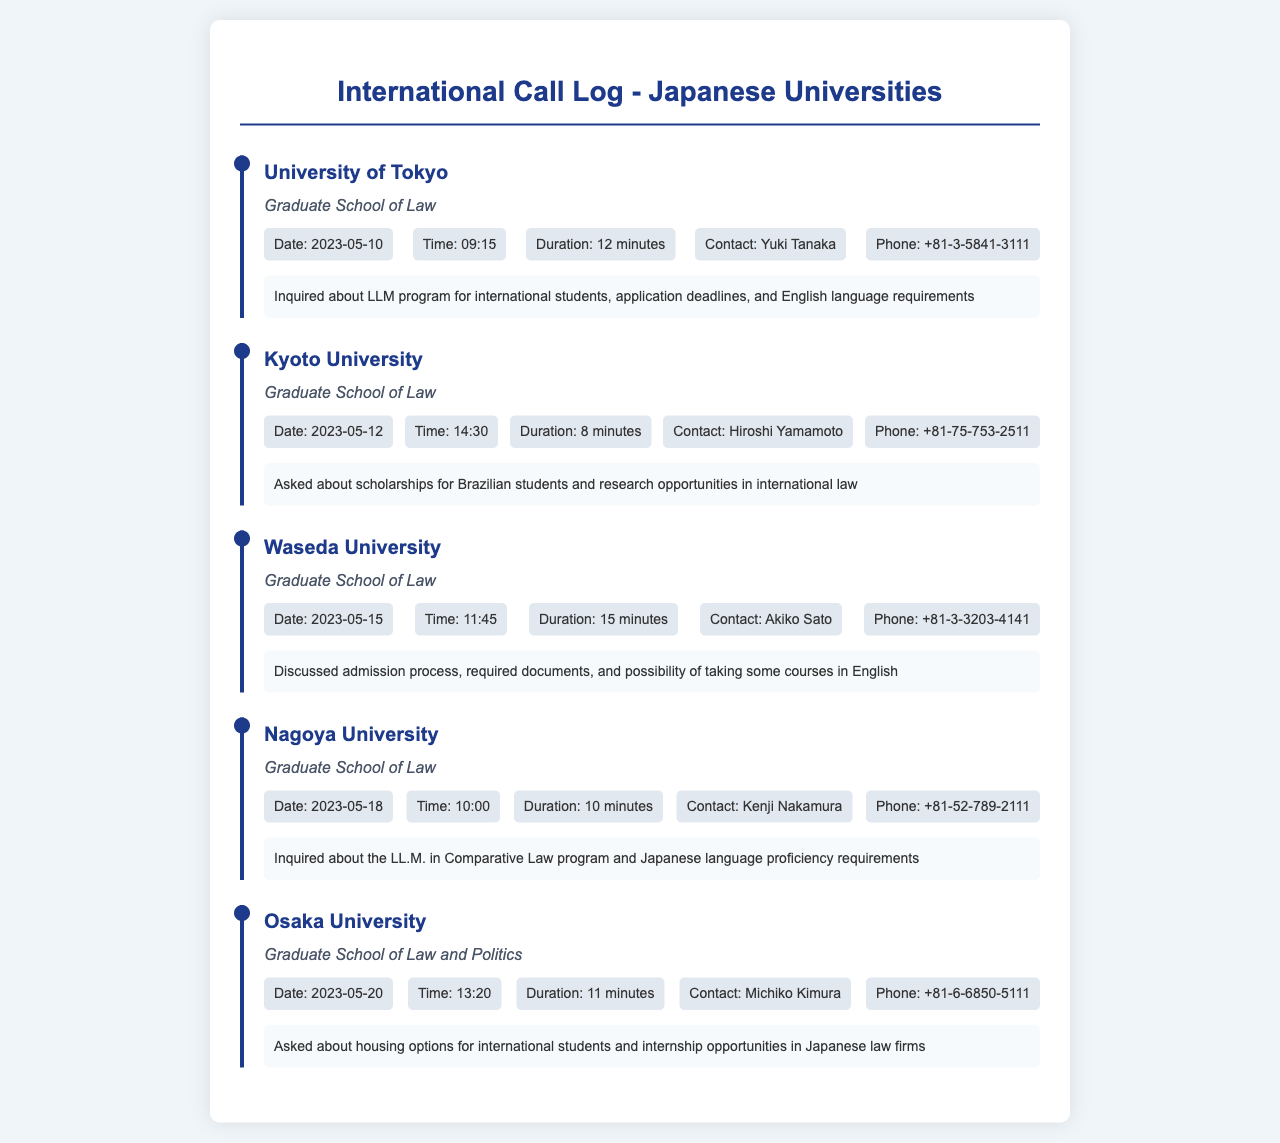what is the date of the call to Kyoto University? The date of the call is a specific piece of information listed in the call log.
Answer: 2023-05-12 who was the contact person at Waseda University? The contact person is mentioned in the details of the call log.
Answer: Akiko Sato how long was the call to Nagoya University? The duration of the call indicates the length of the conversation.
Answer: 10 minutes what information was inquired about during the call to the University of Tokyo? The notes section provides details on the inquiry content.
Answer: LLM program for international students what was discussed during the call to Osaka University? The notes summarize the topics covered during the call.
Answer: housing options for international students which university's department focuses on Law and Politics? The document specifies the department for each university listed.
Answer: Osaka University how many minutes was the shortest call? The duration of each call is noted, allowing a comparison to find the shortest one.
Answer: 8 minutes what is the phone number for the Graduate School of Law at Kyoto University? The phone number is provided in the call log details for each university.
Answer: +81-75-753-2511 which call had the longest duration? By comparing the durations noted in the call logs, the longest can be identified.
Answer: Waseda University (15 minutes) 